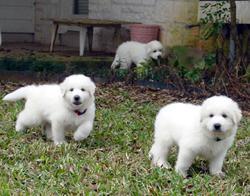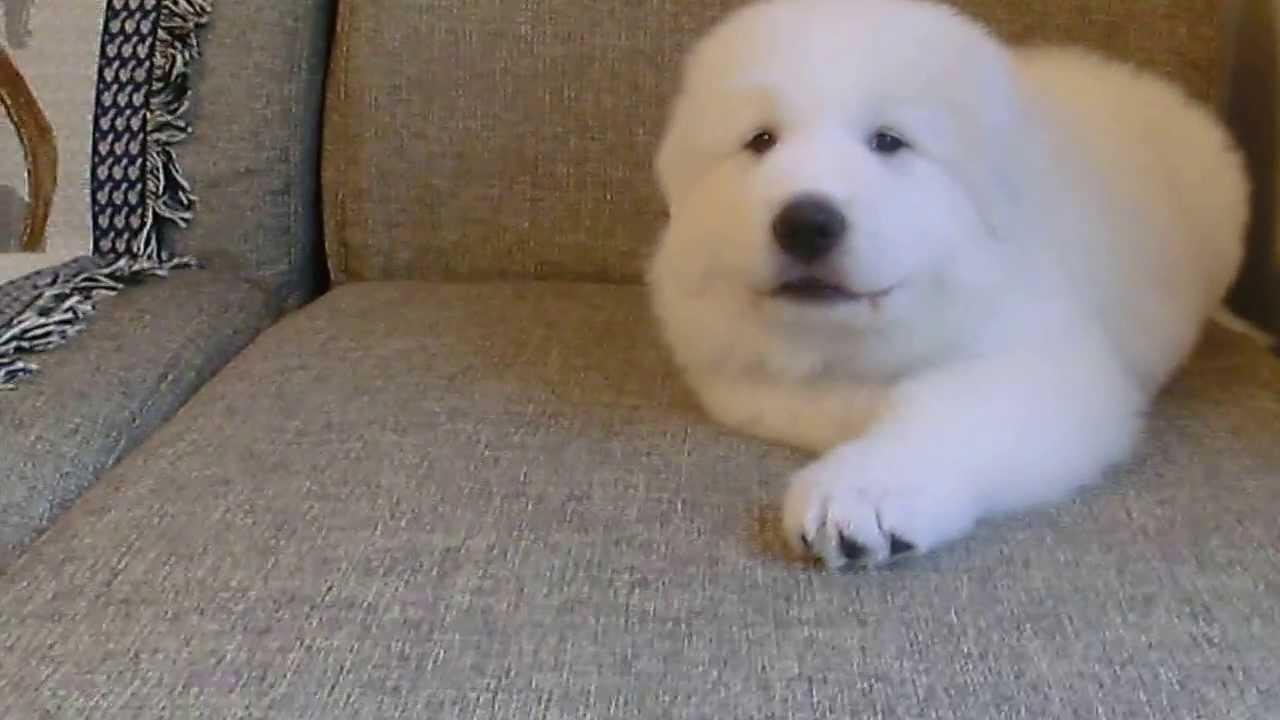The first image is the image on the left, the second image is the image on the right. Evaluate the accuracy of this statement regarding the images: "One image includes at least twice as many white dogs as the other image.". Is it true? Answer yes or no. Yes. The first image is the image on the left, the second image is the image on the right. Considering the images on both sides, is "At least one dog has its mouth open." valid? Answer yes or no. No. 